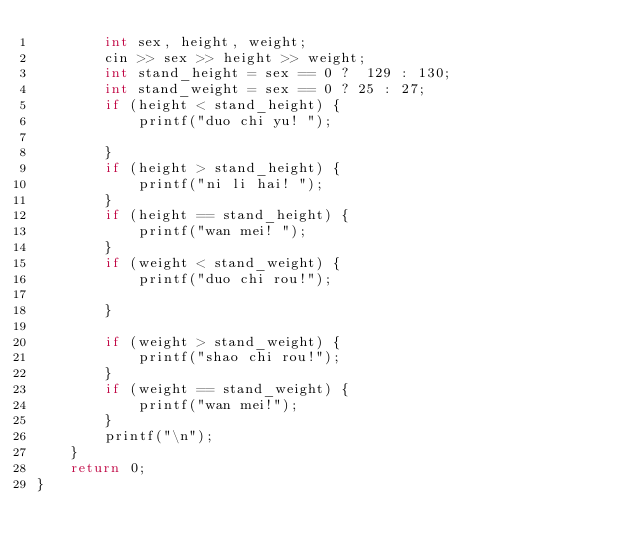Convert code to text. <code><loc_0><loc_0><loc_500><loc_500><_C++_>        int sex, height, weight;
        cin >> sex >> height >> weight;
        int stand_height = sex == 0 ?  129 : 130;
        int stand_weight = sex == 0 ? 25 : 27;
        if (height < stand_height) {
            printf("duo chi yu! ");
            
        }
        if (height > stand_height) {
            printf("ni li hai! ");
        }
        if (height == stand_height) {
            printf("wan mei! ");
        }
        if (weight < stand_weight) {
            printf("duo chi rou!");
            
        }
       
        if (weight > stand_weight) {
            printf("shao chi rou!");
        }
        if (weight == stand_weight) {
            printf("wan mei!");
        }
        printf("\n");
    }
    return 0;
}
</code> 